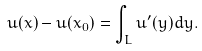Convert formula to latex. <formula><loc_0><loc_0><loc_500><loc_500>u ( x ) - u ( x _ { 0 } ) = \int _ { L } u ^ { \prime } ( y ) d y .</formula> 